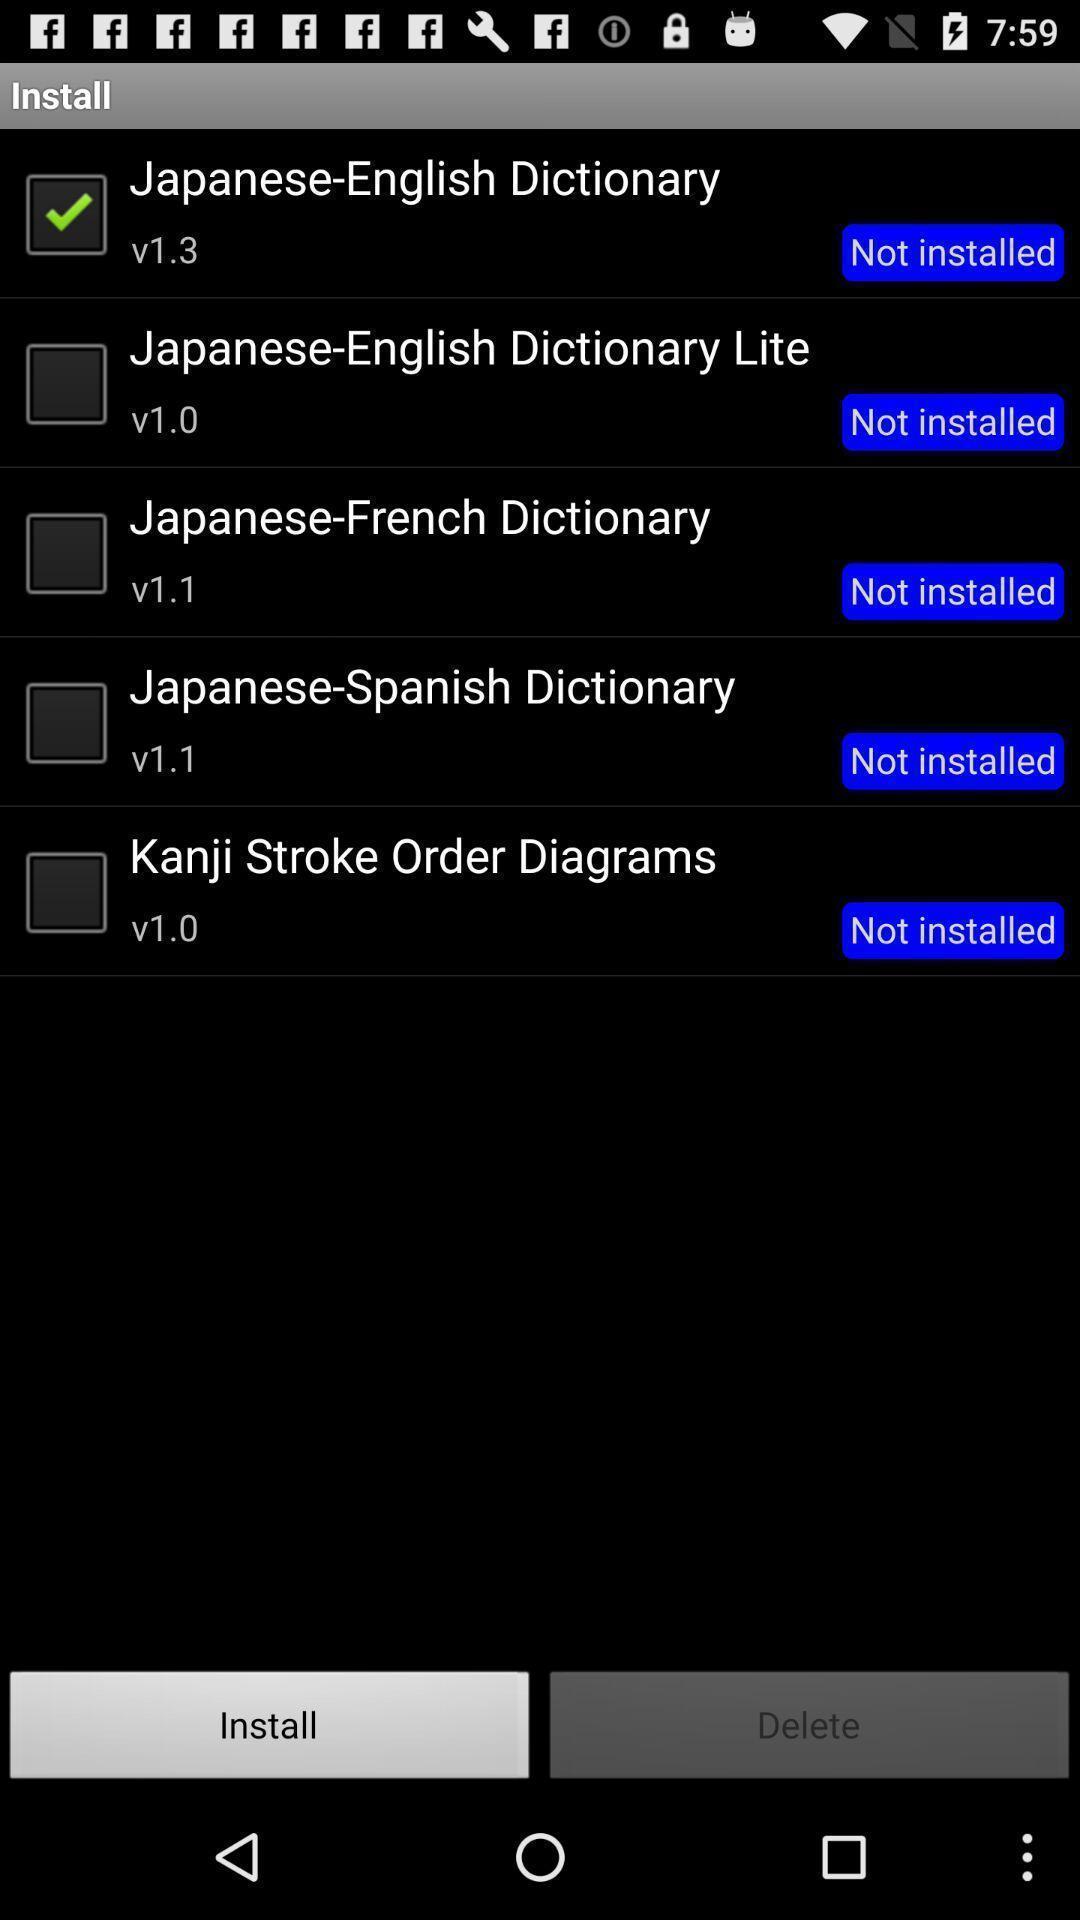Describe the visual elements of this screenshot. Page showing option like install. 